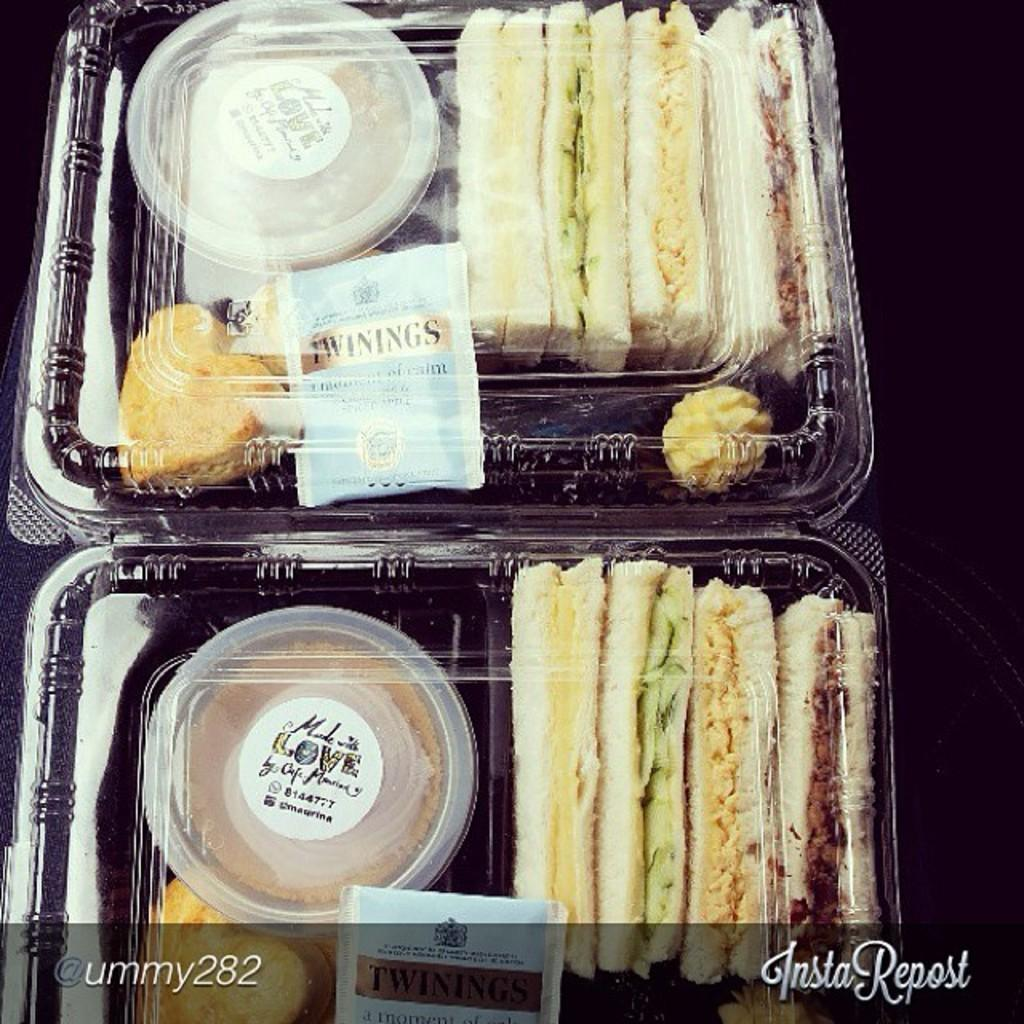What type of containers are the food items stored in? The food items are stored in plastic containers in the image. Can you describe the text at the bottom of the image? Unfortunately, the details about the text at the bottom of the image are not provided in the facts. However, we can confirm that there is text present. What type of ear is visible in the image? There is no ear present in the image. How does the toothpaste relate to the food items in the image? There is no toothpaste mentioned or visible in the image. 